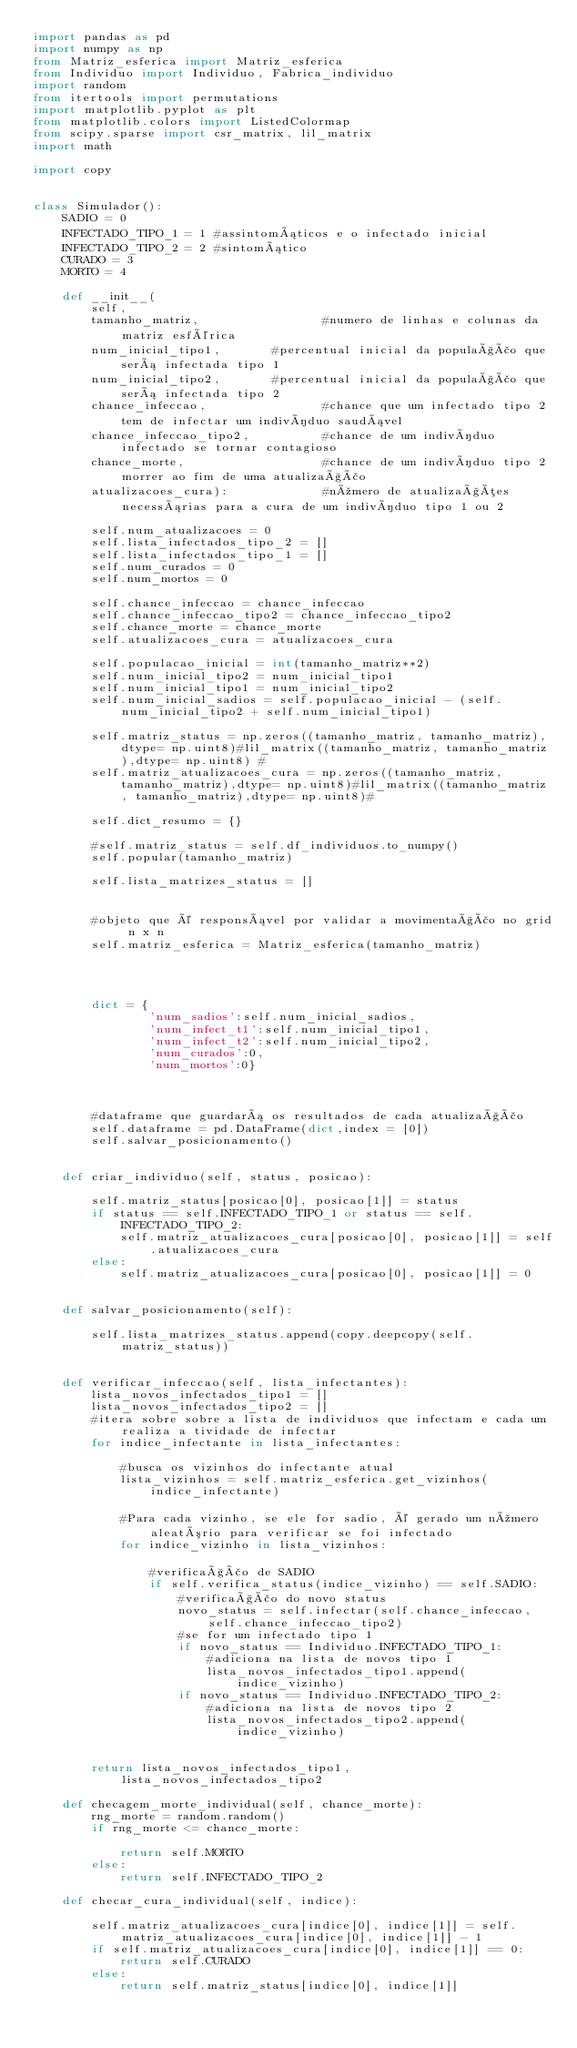Convert code to text. <code><loc_0><loc_0><loc_500><loc_500><_Python_>import pandas as pd
import numpy as np
from Matriz_esferica import Matriz_esferica
from Individuo import Individuo, Fabrica_individuo
import random
from itertools import permutations 
import matplotlib.pyplot as plt
from matplotlib.colors import ListedColormap
from scipy.sparse import csr_matrix, lil_matrix
import math

import copy


class Simulador():
    SADIO = 0
    INFECTADO_TIPO_1 = 1 #assintomáticos e o infectado inicial
    INFECTADO_TIPO_2 = 2 #sintomático
    CURADO = 3
    MORTO = 4

    def __init__(
        self,
        tamanho_matriz,                 #numero de linhas e colunas da matriz esférica
        num_inicial_tipo1,       #percentual inicial da população que será infectada tipo 1
        num_inicial_tipo2,       #percentual inicial da população que será infectada tipo 2
        chance_infeccao,                #chance que um infectado tipo 2 tem de infectar um indivíduo saudável
        chance_infeccao_tipo2,          #chance de um indivíduo infectado se tornar contagioso
        chance_morte,                   #chance de um indivíduo tipo 2 morrer ao fim de uma atualização
        atualizacoes_cura):             #número de atualizações necessárias para a cura de um indivíduo tipo 1 ou 2
        
        self.num_atualizacoes = 0       
        self.lista_infectados_tipo_2 = []
        self.lista_infectados_tipo_1 = []
        self.num_curados = 0
        self.num_mortos = 0

        self.chance_infeccao = chance_infeccao
        self.chance_infeccao_tipo2 = chance_infeccao_tipo2
        self.chance_morte = chance_morte
        self.atualizacoes_cura = atualizacoes_cura
        
        self.populacao_inicial = int(tamanho_matriz**2)
        self.num_inicial_tipo2 = num_inicial_tipo1
        self.num_inicial_tipo1 = num_inicial_tipo2
        self.num_inicial_sadios = self.populacao_inicial - (self.num_inicial_tipo2 + self.num_inicial_tipo1)
       
        self.matriz_status = np.zeros((tamanho_matriz, tamanho_matriz),dtype= np.uint8)#lil_matrix((tamanho_matriz, tamanho_matriz),dtype= np.uint8) #
        self.matriz_atualizacoes_cura = np.zeros((tamanho_matriz, tamanho_matriz),dtype= np.uint8)#lil_matrix((tamanho_matriz, tamanho_matriz),dtype= np.uint8)#
            
        self.dict_resumo = {}

        #self.matriz_status = self.df_individuos.to_numpy()
        self.popular(tamanho_matriz)
      
        self.lista_matrizes_status = []
        

        #objeto que é responsável por validar a movimentação no grid n x n    
        self.matriz_esferica = Matriz_esferica(tamanho_matriz)
         
        

       
        dict = {
                'num_sadios':self.num_inicial_sadios,
                'num_infect_t1':self.num_inicial_tipo1,
                'num_infect_t2':self.num_inicial_tipo2,
                'num_curados':0,
                'num_mortos':0}
            
        
            
        #dataframe que guardará os resultados de cada atualização  
        self.dataframe = pd.DataFrame(dict,index = [0])
        self.salvar_posicionamento()
    
    
    def criar_individuo(self, status, posicao):
        
        self.matriz_status[posicao[0], posicao[1]] = status
        if status == self.INFECTADO_TIPO_1 or status == self.INFECTADO_TIPO_2:
            self.matriz_atualizacoes_cura[posicao[0], posicao[1]] = self.atualizacoes_cura
        else:
            self.matriz_atualizacoes_cura[posicao[0], posicao[1]] = 0   
        

    def salvar_posicionamento(self):
        
        self.lista_matrizes_status.append(copy.deepcopy(self.matriz_status))
        

    def verificar_infeccao(self, lista_infectantes):
        lista_novos_infectados_tipo1 = []
        lista_novos_infectados_tipo2 = []
        #itera sobre sobre a lista de individuos que infectam e cada um realiza a tividade de infectar
        for indice_infectante in lista_infectantes:            
           
            #busca os vizinhos do infectante atual
            lista_vizinhos = self.matriz_esferica.get_vizinhos(indice_infectante)
           
            #Para cada vizinho, se ele for sadio, é gerado um número aleatório para verificar se foi infectado
            for indice_vizinho in lista_vizinhos:
                
                #verificação de SADIO
                if self.verifica_status(indice_vizinho) == self.SADIO:
                    #verificação do novo status
                    novo_status = self.infectar(self.chance_infeccao, self.chance_infeccao_tipo2)
                    #se for um infectado tipo 1
                    if novo_status == Individuo.INFECTADO_TIPO_1:
                        #adiciona na lista de novos tipo 1
                        lista_novos_infectados_tipo1.append(indice_vizinho)
                    if novo_status == Individuo.INFECTADO_TIPO_2:
                        #adiciona na lista de novos tipo 2
                        lista_novos_infectados_tipo2.append(indice_vizinho)
                        
               
        return lista_novos_infectados_tipo1, lista_novos_infectados_tipo2
    
    def checagem_morte_individual(self, chance_morte):
        rng_morte = random.random()
        if rng_morte <= chance_morte:
            
            return self.MORTO
        else:
            return self.INFECTADO_TIPO_2

    def checar_cura_individual(self, indice):
              
        self.matriz_atualizacoes_cura[indice[0], indice[1]] = self.matriz_atualizacoes_cura[indice[0], indice[1]] - 1
        if self.matriz_atualizacoes_cura[indice[0], indice[1]] == 0:
            return self.CURADO
        else:
            return self.matriz_status[indice[0], indice[1]]
</code> 